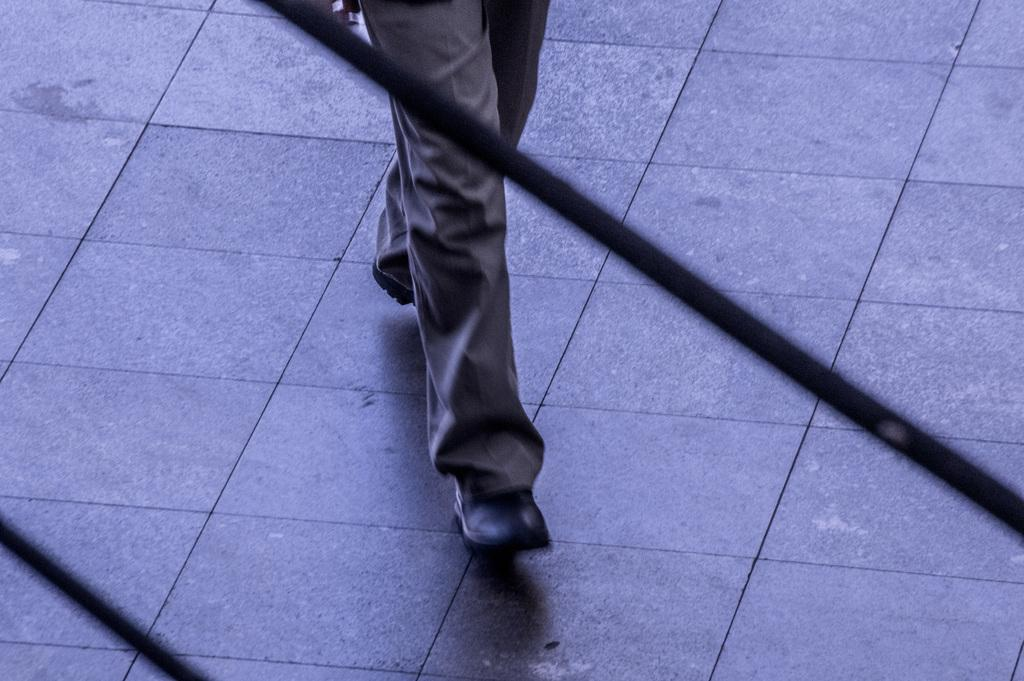What part of a person can be seen in the image? There are legs of a person in the image. What type of surface is visible beneath the person? The floor is visible in the image. What color are the objects in the image? The objects in the image are black. Can you see a kitty playing with a hydrant in the image? There is no kitty or hydrant present in the image. 